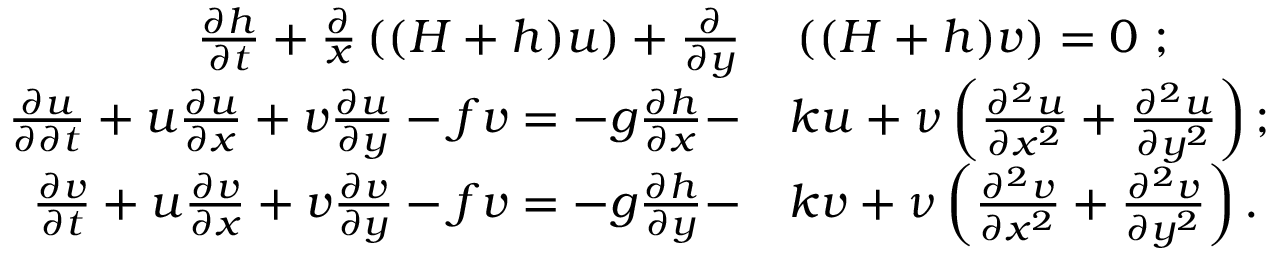Convert formula to latex. <formula><loc_0><loc_0><loc_500><loc_500>\begin{array} { r l } { \frac { \partial h } { \partial t } + \frac { \partial } { x } \left ( ( H + h ) u \right ) + \frac { \partial } { \partial y } } & \left ( ( H + h ) v \right ) = 0 \ ; } \\ { \frac { \partial u } { \partial \partial t } + u \frac { \partial u } { \partial x } + v \frac { \partial u } { \partial y } - f v = - g \frac { \partial h } { \partial x } - } & k u + \nu \left ( \frac { \partial ^ { 2 } u } { \partial x ^ { 2 } } + \frac { \partial ^ { 2 } u } { \partial y ^ { 2 } } \right ) ; } \\ { \frac { \partial v } { \partial t } + u \frac { \partial v } { \partial x } + v \frac { \partial v } { \partial y } - f v = - g \frac { \partial h } { \partial y } - } & k v + \nu \left ( \frac { \partial ^ { 2 } v } { \partial x ^ { 2 } } + \frac { \partial ^ { 2 } v } { \partial y ^ { 2 } } \right ) . } \end{array}</formula> 